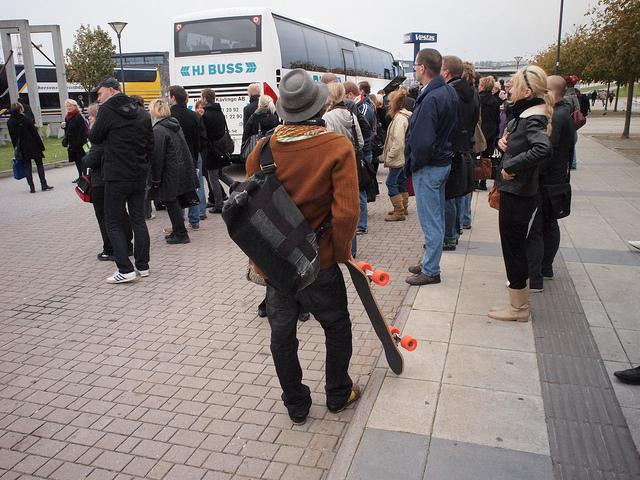What kind of bus is the white vehicle? Please explain your reasoning. tourist bus. It is to move people around who are visiting the area 